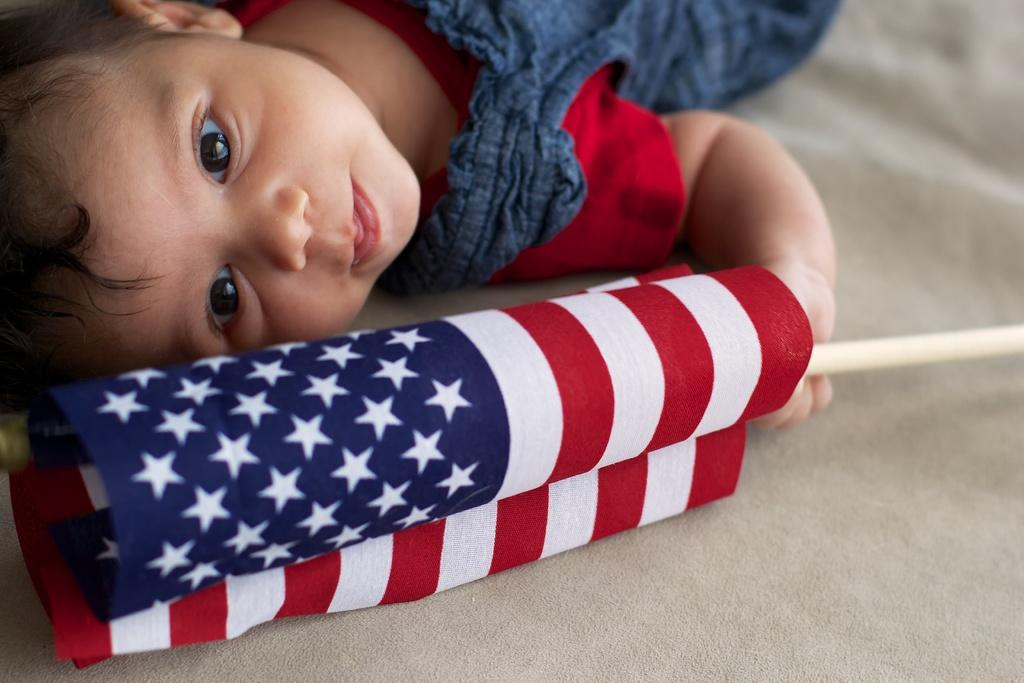What is the main subject of the image? The main subject of the image is a baby. What is the baby wearing in the image? The baby is wearing clothes in the image. What is the baby holding in the image? The baby is holding a flag with his hand in the image. What type of soap is the baby using to rub the seat in the image? There is no soap, rubbing, or seat present in the image; it features a baby holding a flag. 